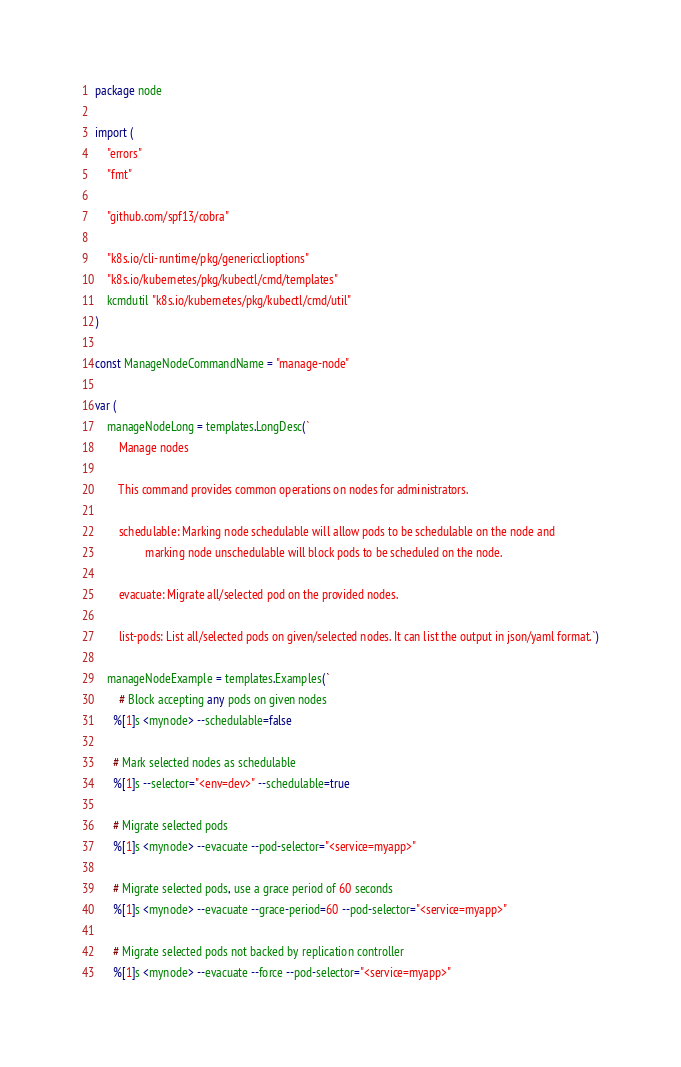<code> <loc_0><loc_0><loc_500><loc_500><_Go_>package node

import (
	"errors"
	"fmt"

	"github.com/spf13/cobra"

	"k8s.io/cli-runtime/pkg/genericclioptions"
	"k8s.io/kubernetes/pkg/kubectl/cmd/templates"
	kcmdutil "k8s.io/kubernetes/pkg/kubectl/cmd/util"
)

const ManageNodeCommandName = "manage-node"

var (
	manageNodeLong = templates.LongDesc(`
		Manage nodes

		This command provides common operations on nodes for administrators.

		schedulable: Marking node schedulable will allow pods to be schedulable on the node and
				 marking node unschedulable will block pods to be scheduled on the node.

		evacuate: Migrate all/selected pod on the provided nodes.

		list-pods: List all/selected pods on given/selected nodes. It can list the output in json/yaml format.`)

	manageNodeExample = templates.Examples(`
		# Block accepting any pods on given nodes
	  %[1]s <mynode> --schedulable=false

	  # Mark selected nodes as schedulable
	  %[1]s --selector="<env=dev>" --schedulable=true

	  # Migrate selected pods
	  %[1]s <mynode> --evacuate --pod-selector="<service=myapp>"

	  # Migrate selected pods, use a grace period of 60 seconds
	  %[1]s <mynode> --evacuate --grace-period=60 --pod-selector="<service=myapp>"

	  # Migrate selected pods not backed by replication controller
	  %[1]s <mynode> --evacuate --force --pod-selector="<service=myapp>"
</code> 